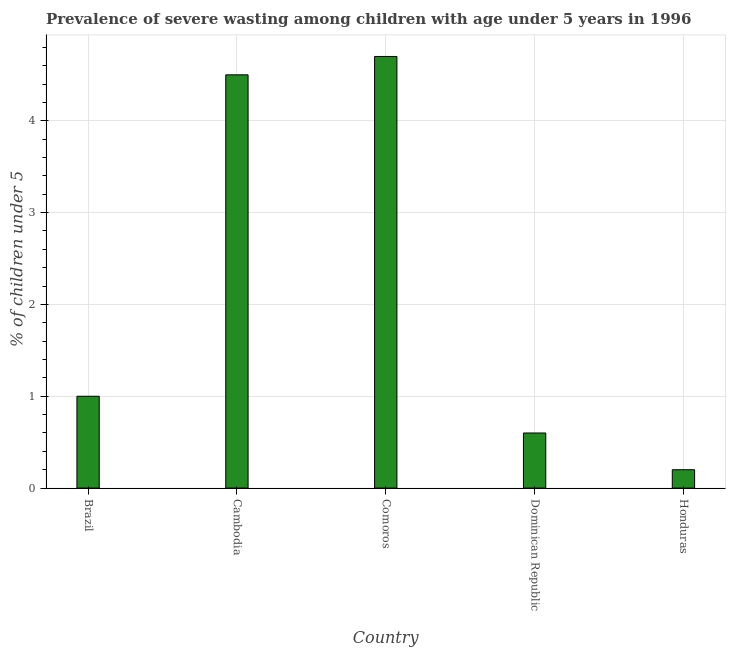Does the graph contain grids?
Ensure brevity in your answer.  Yes. What is the title of the graph?
Offer a terse response. Prevalence of severe wasting among children with age under 5 years in 1996. What is the label or title of the Y-axis?
Ensure brevity in your answer.   % of children under 5. What is the prevalence of severe wasting in Comoros?
Provide a succinct answer. 4.7. Across all countries, what is the maximum prevalence of severe wasting?
Your answer should be very brief. 4.7. Across all countries, what is the minimum prevalence of severe wasting?
Provide a succinct answer. 0.2. In which country was the prevalence of severe wasting maximum?
Your answer should be compact. Comoros. In which country was the prevalence of severe wasting minimum?
Provide a succinct answer. Honduras. What is the sum of the prevalence of severe wasting?
Provide a short and direct response. 11. What is the average prevalence of severe wasting per country?
Offer a terse response. 2.2. Is the difference between the prevalence of severe wasting in Cambodia and Dominican Republic greater than the difference between any two countries?
Keep it short and to the point. No. What is the difference between the highest and the second highest prevalence of severe wasting?
Provide a short and direct response. 0.2. In how many countries, is the prevalence of severe wasting greater than the average prevalence of severe wasting taken over all countries?
Your answer should be very brief. 2. How many bars are there?
Your response must be concise. 5. What is the difference between two consecutive major ticks on the Y-axis?
Your response must be concise. 1. What is the  % of children under 5 in Brazil?
Your response must be concise. 1. What is the  % of children under 5 of Cambodia?
Your response must be concise. 4.5. What is the  % of children under 5 in Comoros?
Provide a short and direct response. 4.7. What is the  % of children under 5 of Dominican Republic?
Provide a succinct answer. 0.6. What is the  % of children under 5 in Honduras?
Keep it short and to the point. 0.2. What is the difference between the  % of children under 5 in Brazil and Cambodia?
Make the answer very short. -3.5. What is the difference between the  % of children under 5 in Cambodia and Comoros?
Offer a very short reply. -0.2. What is the difference between the  % of children under 5 in Cambodia and Honduras?
Provide a short and direct response. 4.3. What is the difference between the  % of children under 5 in Comoros and Dominican Republic?
Provide a succinct answer. 4.1. What is the ratio of the  % of children under 5 in Brazil to that in Cambodia?
Make the answer very short. 0.22. What is the ratio of the  % of children under 5 in Brazil to that in Comoros?
Your response must be concise. 0.21. What is the ratio of the  % of children under 5 in Brazil to that in Dominican Republic?
Offer a very short reply. 1.67. What is the ratio of the  % of children under 5 in Cambodia to that in Dominican Republic?
Provide a succinct answer. 7.5. What is the ratio of the  % of children under 5 in Comoros to that in Dominican Republic?
Keep it short and to the point. 7.83. What is the ratio of the  % of children under 5 in Dominican Republic to that in Honduras?
Provide a succinct answer. 3. 